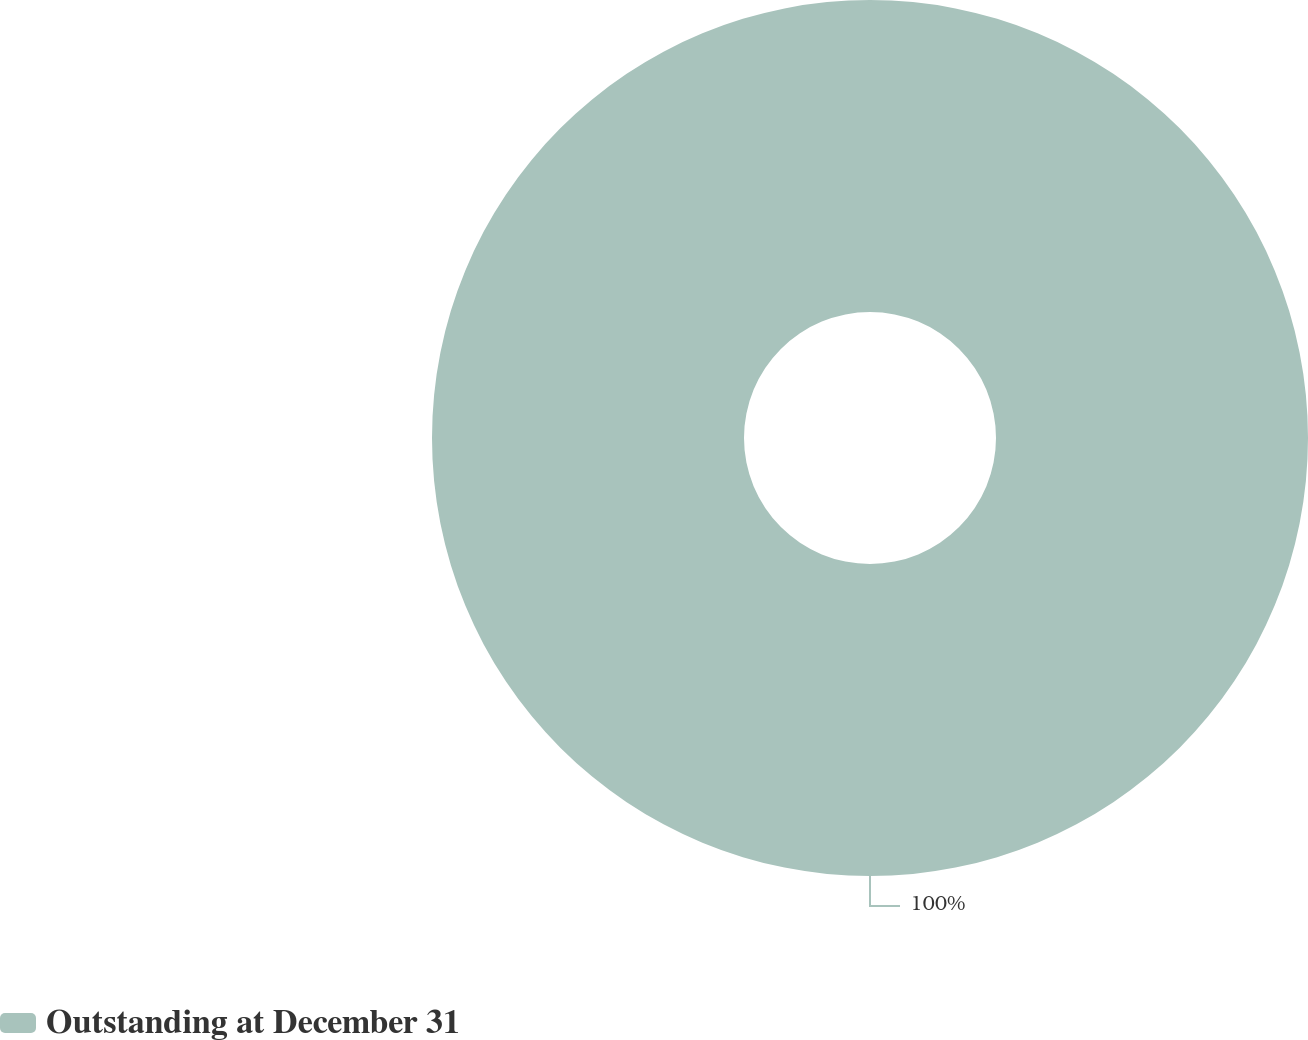Convert chart. <chart><loc_0><loc_0><loc_500><loc_500><pie_chart><fcel>Outstanding at December 31<nl><fcel>100.0%<nl></chart> 